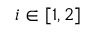<formula> <loc_0><loc_0><loc_500><loc_500>i \in [ 1 , 2 ]</formula> 